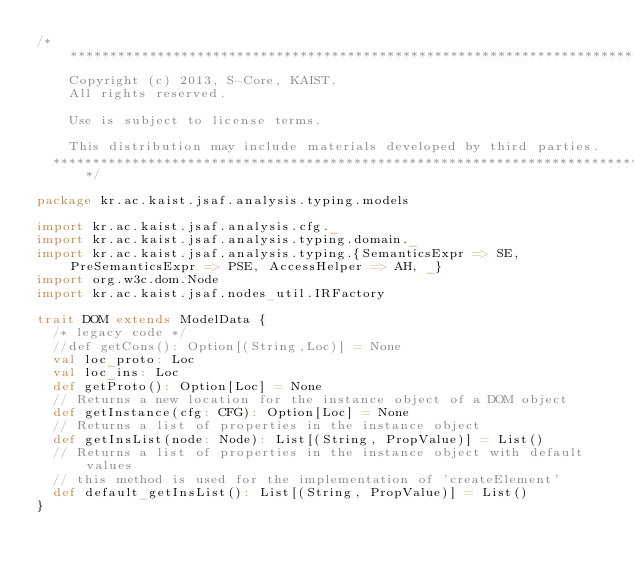<code> <loc_0><loc_0><loc_500><loc_500><_Scala_>/*******************************************************************************
    Copyright (c) 2013, S-Core, KAIST.
    All rights reserved.

    Use is subject to license terms.

    This distribution may include materials developed by third parties.
  ******************************************************************************/

package kr.ac.kaist.jsaf.analysis.typing.models

import kr.ac.kaist.jsaf.analysis.cfg._
import kr.ac.kaist.jsaf.analysis.typing.domain._
import kr.ac.kaist.jsaf.analysis.typing.{SemanticsExpr => SE, PreSemanticsExpr => PSE, AccessHelper => AH, _}
import org.w3c.dom.Node
import kr.ac.kaist.jsaf.nodes_util.IRFactory

trait DOM extends ModelData {
  /* legacy code */
  //def getCons(): Option[(String,Loc)] = None
  val loc_proto: Loc
  val loc_ins: Loc
  def getProto(): Option[Loc] = None
  // Returns a new location for the instance object of a DOM object 
  def getInstance(cfg: CFG): Option[Loc] = None
  // Returns a list of properties in the instance object
  def getInsList(node: Node): List[(String, PropValue)] = List()
  // Returns a list of properties in the instance object with default values
  // this method is used for the implementation of 'createElement'
  def default_getInsList(): List[(String, PropValue)] = List()
}

</code> 